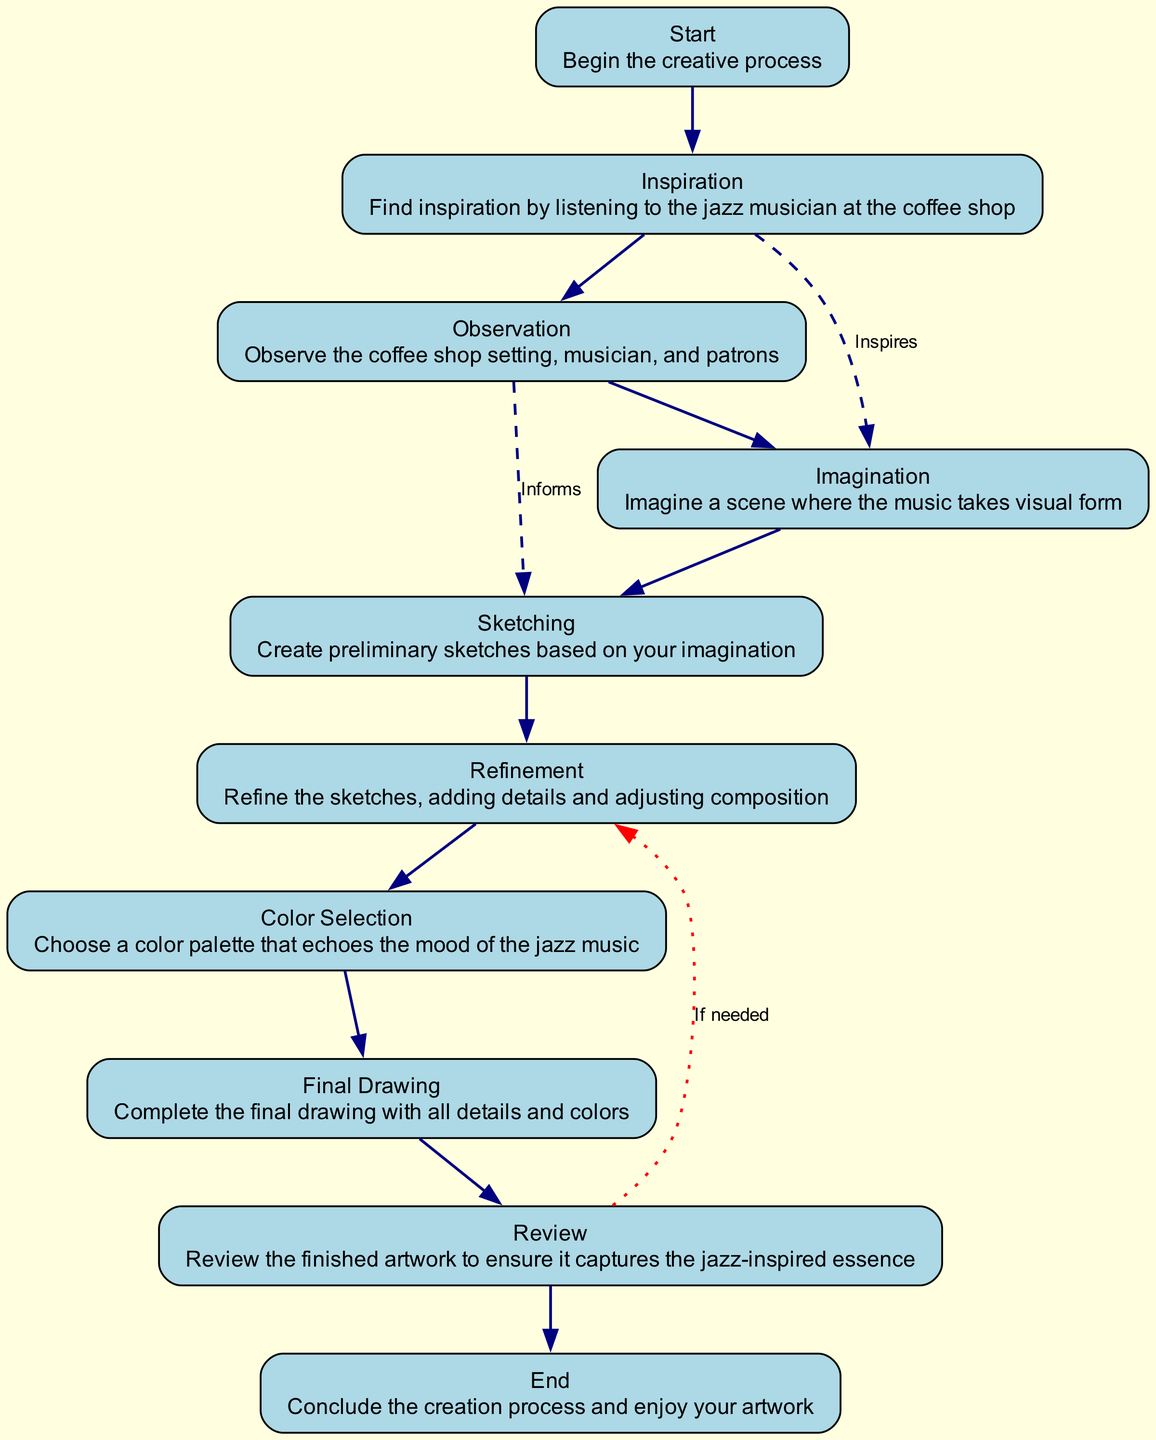What is the first step in the process? The diagram starts with the node labeled 'Start', indicating that it is the initiation point of the creative process.
Answer: Start How many nodes are in the diagram? By counting all the unique nodes listed in the diagram, we find there are 10 nodes in total that represent different steps in the process.
Answer: 10 What is the last step in this creative process? The final node in the flow is 'End', signifying the conclusion of the artwork creation process.
Answer: End Which step follows 'Observation'? The flow indicates that 'Imagination' follows 'Observation', moving from observing the coffee shop setting to imagining a scene based on those observations.
Answer: Imagination What relationship does 'Inspiration' have with 'Imagination'? The diagram shows a dashed edge labeled 'Inspires' connecting 'Inspiration' to 'Imagination', indicating that finding inspiration is a factor that ignites the imagination.
Answer: Inspires What color is used for the nodes in the diagram? The nodes are filled with light blue color as specified in the attributes of the graph, contributing to the overall artistic design of the diagram.
Answer: Light blue What happens if the artwork needs changes after the review? The flowchart specifies a dotted edge labeled 'If needed' connecting 'Review' back to 'Refinement', indicating that if there's a need for changes, the artist revisits the refinement stage after reviewing the artwork.
Answer: If needed What step involves selecting colors? The step that includes choosing the color palette is labeled 'Color Selection' and is an essential part of providing the final artwork with expressive qualities that reflect the music's mood.
Answer: Color Selection How does 'Observation' influence the 'Sketching' process? The diagram highlights a dashed edge labeled 'Informs' running from 'Observation' to 'Sketching', indicating that observing the surrounding elements informs and guides the sketching stage.
Answer: Informs What is the purpose of 'Refinement' in the process? The 'Refinement' step serves the purpose of adding details and adjusting the composition of the sketches, which helps to enhance the overall quality of the artwork being created.
Answer: Adding details 